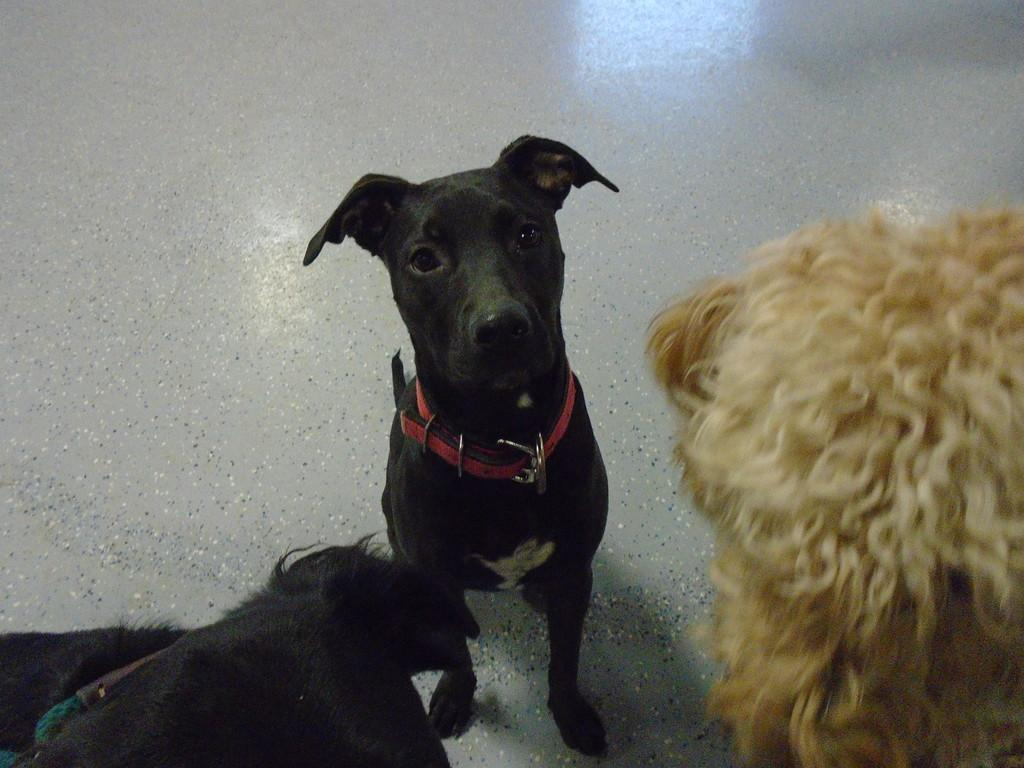How many dogs are present in the image? There are three dogs in the image. What distinguishing feature do the dogs have? The dogs are wearing a belt around their necks. What surface can be seen in the image? There is a floor visible in the image. What type of pest can be seen crawling on the floor in the image? There is no pest visible in the image; the focus is on the three dogs and their belts. 